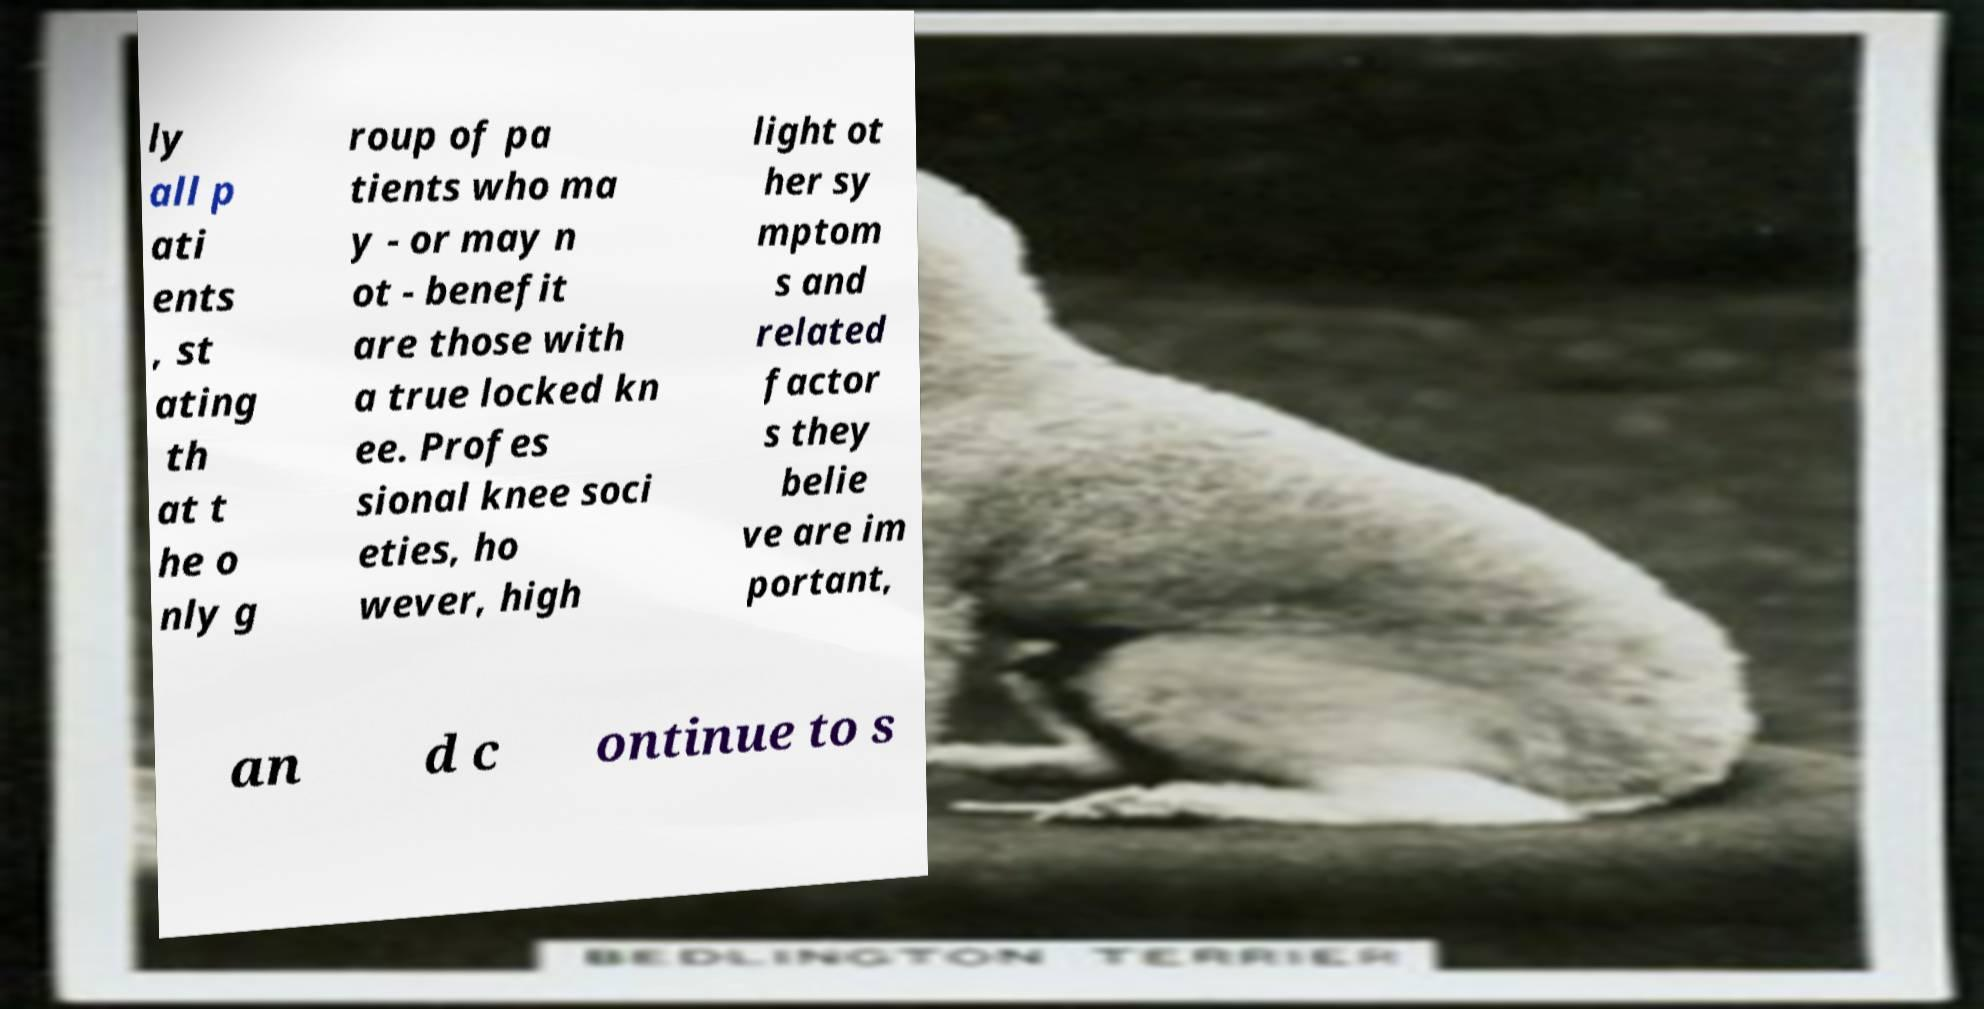What messages or text are displayed in this image? I need them in a readable, typed format. ly all p ati ents , st ating th at t he o nly g roup of pa tients who ma y - or may n ot - benefit are those with a true locked kn ee. Profes sional knee soci eties, ho wever, high light ot her sy mptom s and related factor s they belie ve are im portant, an d c ontinue to s 